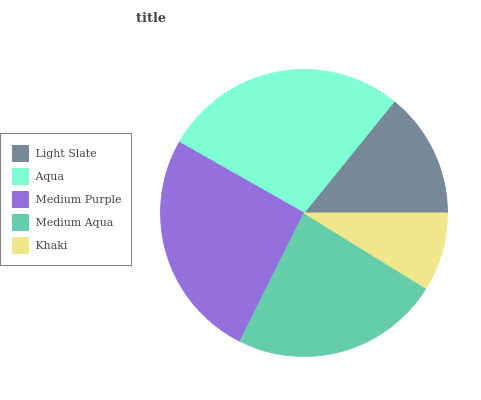Is Khaki the minimum?
Answer yes or no. Yes. Is Aqua the maximum?
Answer yes or no. Yes. Is Medium Purple the minimum?
Answer yes or no. No. Is Medium Purple the maximum?
Answer yes or no. No. Is Aqua greater than Medium Purple?
Answer yes or no. Yes. Is Medium Purple less than Aqua?
Answer yes or no. Yes. Is Medium Purple greater than Aqua?
Answer yes or no. No. Is Aqua less than Medium Purple?
Answer yes or no. No. Is Medium Aqua the high median?
Answer yes or no. Yes. Is Medium Aqua the low median?
Answer yes or no. Yes. Is Light Slate the high median?
Answer yes or no. No. Is Khaki the low median?
Answer yes or no. No. 